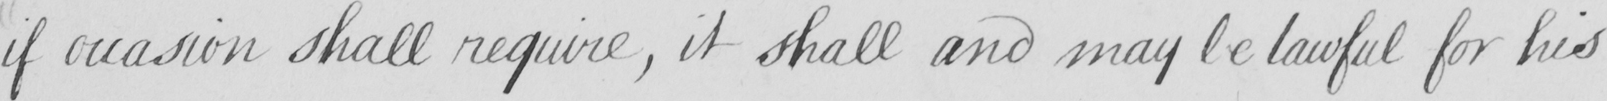What text is written in this handwritten line? if occasion shall require , it shall and may be lawful for his 